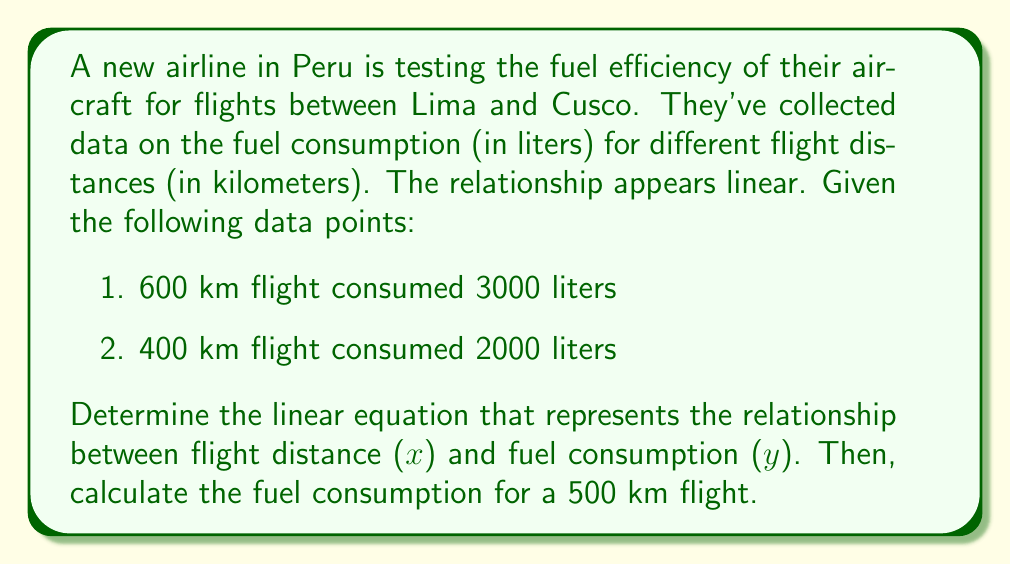Provide a solution to this math problem. Let's approach this step-by-step:

1) We'll use the point-slope form of a linear equation: $y - y_1 = m(x - x_1)$

2) First, we need to calculate the slope (m):
   $m = \frac{y_2 - y_1}{x_2 - x_1} = \frac{3000 - 2000}{600 - 400} = \frac{1000}{200} = 5$

3) Now we can use either point to form our equation. Let's use (400, 2000):
   $y - 2000 = 5(x - 400)$

4) Simplify:
   $y = 5(x - 400) + 2000$
   $y = 5x - 2000 + 2000$
   $y = 5x$

5) Therefore, our linear equation is $y = 5x$

6) To find the fuel consumption for a 500 km flight, we substitute x = 500:
   $y = 5(500) = 2500$

Thus, a 500 km flight would consume 2500 liters of fuel.
Answer: $y = 5x$; 2500 liters 